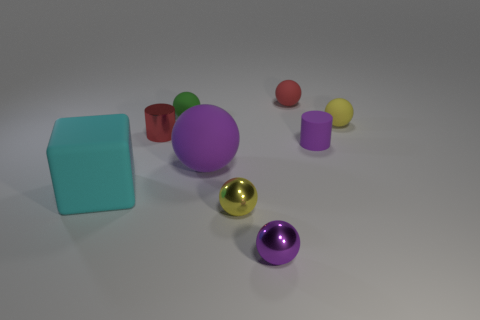Are there any objects that seem to have a similar color but different textures? Yes, the large purple sphere and the small purple cylinder have similar colors but different textures. The sphere has a matte finish, diffusing the light, while the cylinder has a glossy surface that reflects light. 